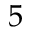<formula> <loc_0><loc_0><loc_500><loc_500>5</formula> 